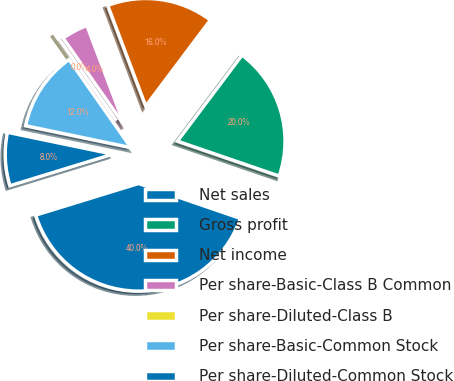<chart> <loc_0><loc_0><loc_500><loc_500><pie_chart><fcel>Net sales<fcel>Gross profit<fcel>Net income<fcel>Per share-Basic-Class B Common<fcel>Per share-Diluted-Class B<fcel>Per share-Basic-Common Stock<fcel>Per share-Diluted-Common Stock<nl><fcel>40.0%<fcel>20.0%<fcel>16.0%<fcel>4.0%<fcel>0.0%<fcel>12.0%<fcel>8.0%<nl></chart> 